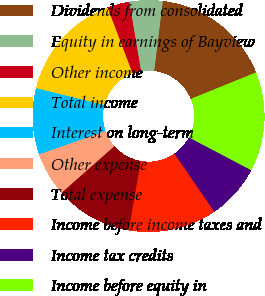Convert chart. <chart><loc_0><loc_0><loc_500><loc_500><pie_chart><fcel>Dividends from consolidated<fcel>Equity in earnings of Bayview<fcel>Other income<fcel>Total income<fcel>Interest on long-term<fcel>Other expense<fcel>Total expense<fcel>Income before income taxes and<fcel>Income tax credits<fcel>Income before equity in<nl><fcel>16.92%<fcel>4.62%<fcel>3.08%<fcel>15.38%<fcel>9.23%<fcel>6.15%<fcel>10.77%<fcel>12.31%<fcel>7.69%<fcel>13.85%<nl></chart> 